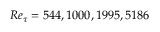<formula> <loc_0><loc_0><loc_500><loc_500>R e _ { \tau } = 5 4 4 , 1 0 0 0 , 1 9 9 5 , 5 1 8 6</formula> 